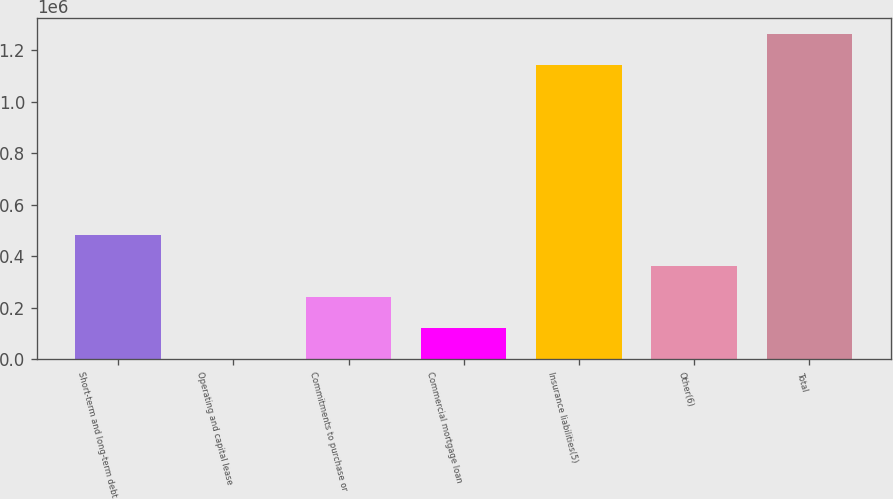Convert chart. <chart><loc_0><loc_0><loc_500><loc_500><bar_chart><fcel>Short-term and long-term debt<fcel>Operating and capital lease<fcel>Commitments to purchase or<fcel>Commercial mortgage loan<fcel>Insurance liabilities(5)<fcel>Other(6)<fcel>Total<nl><fcel>483336<fcel>685<fcel>242011<fcel>121348<fcel>1.1423e+06<fcel>362673<fcel>1.26296e+06<nl></chart> 